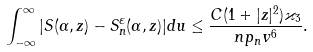Convert formula to latex. <formula><loc_0><loc_0><loc_500><loc_500>\int _ { - \infty } ^ { \infty } | S ( \alpha , z ) - S _ { n } ^ { \varepsilon } ( \alpha , z ) | d u \leq \frac { C ( 1 + | z | ^ { 2 } ) \varkappa _ { 3 } } { n p _ { n } v ^ { 6 } } .</formula> 